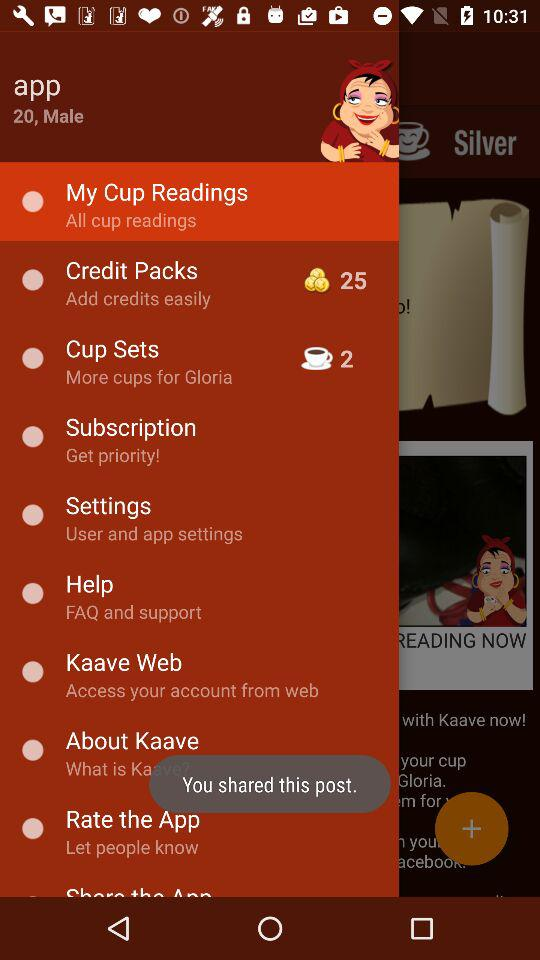How many sets of cups are there? There are 2 sets of cups. 